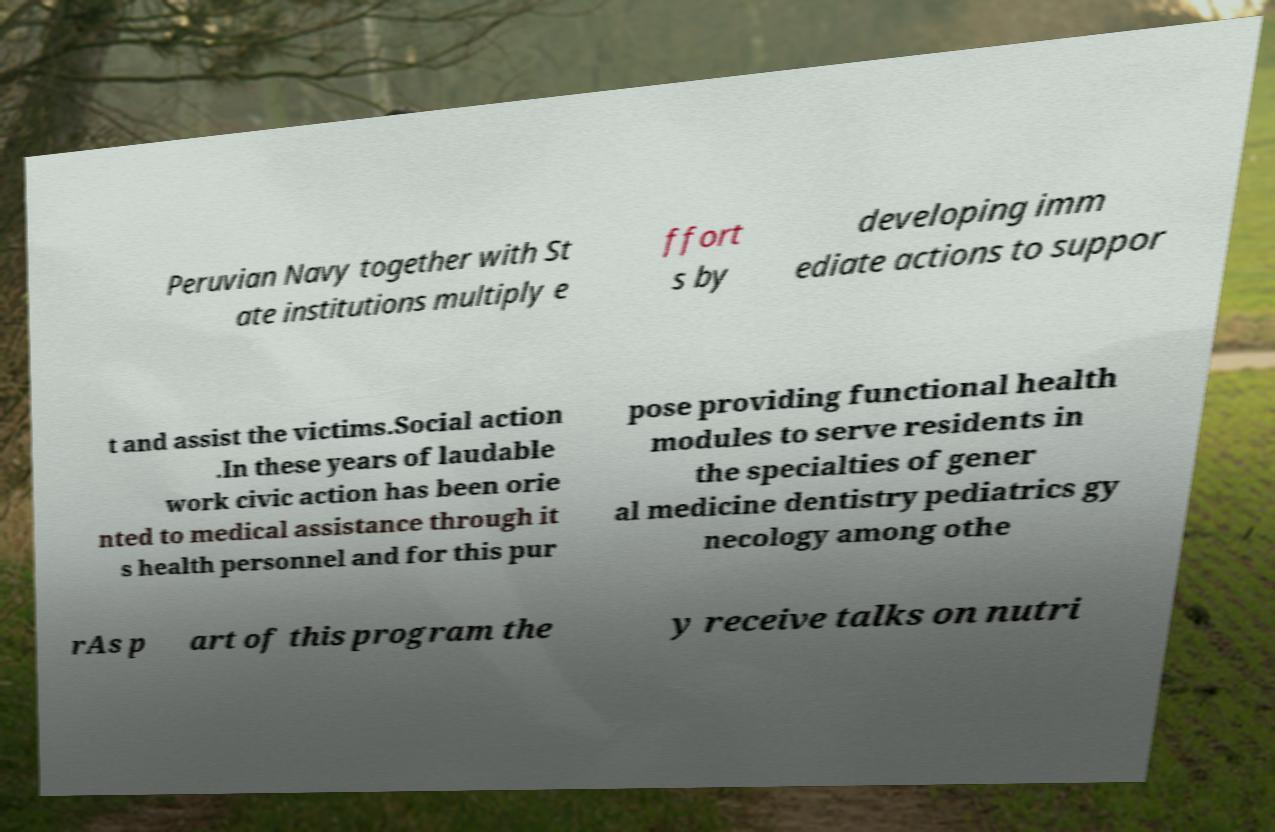I need the written content from this picture converted into text. Can you do that? Peruvian Navy together with St ate institutions multiply e ffort s by developing imm ediate actions to suppor t and assist the victims.Social action .In these years of laudable work civic action has been orie nted to medical assistance through it s health personnel and for this pur pose providing functional health modules to serve residents in the specialties of gener al medicine dentistry pediatrics gy necology among othe rAs p art of this program the y receive talks on nutri 